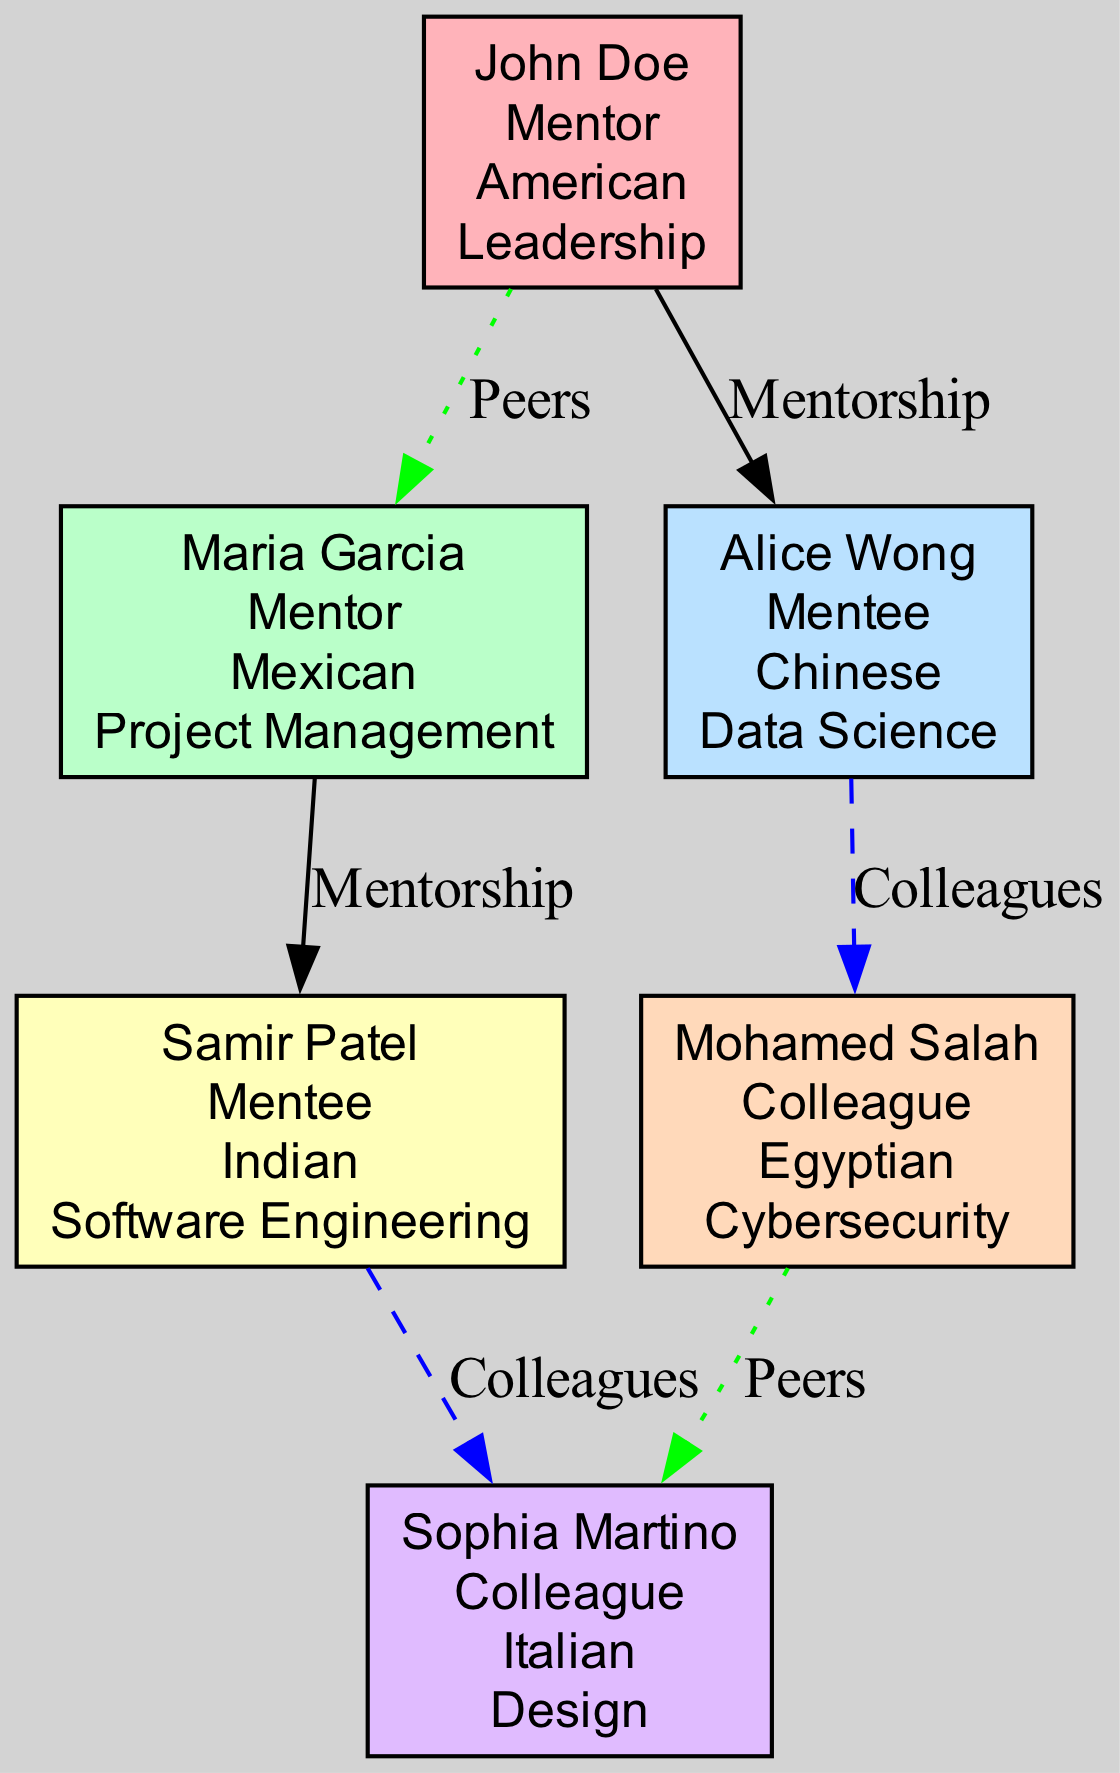What is John Doe's specialty? John Doe's node indicates that his specialty is "Leadership". By looking at the information in his node, we can directly find the specialty listed there.
Answer: Leadership How many mentees are represented in the diagram? The diagram shows two mentees: Alice Wong and Samir Patel. By counting the nodes with the role "Mentee", we find there are a total of two.
Answer: 2 What kind of relationship exists between Maria Garcia and Samir Patel? Since Maria Garcia is a mentor and Samir Patel is a mentee, the relationship is one of "Mentorship". However, we need to check the connections, and there is no direct connection between them. Therefore, the relationship is "None".
Answer: None Which cultural background does Sophia Martino represent? Sophia Martino's node lists her cultural background as "Italian". We can find this information directly in her node.
Answer: Italian What are the specialities of the colleagues listed in the diagram? The diagram includes two colleagues: Mohamed Salah, whose specialty is "Cybersecurity", and Sophia Martino, whose specialty is "Design". To find the specialties, we look at each colleague's node.
Answer: Cybersecurity and Design Who are the peers of John Doe? The diagram shows that John Doe has one peer, which is Maria Garcia. By examining the connections, we can identify that they are connected as peers.
Answer: Maria Garcia Which mentor specializes in Project Management? Maria Garcia's node specifies that her specialty is "Project Management". This information can be accessed directly from her node in the diagram.
Answer: Project Management How many connections are represented in the diagram? The total number of connections in the diagram is six as listed. We can count the connections shown in the data to reach this conclusion.
Answer: 6 What type of relationship do Alice Wong and Mohamed Salah have? Alice Wong and Mohamed Salah are connected through the relationship labeled "Colleagues". This relationship category can be verified by examining the connections in the diagram.
Answer: Colleagues What is the cultural background of Samir Patel? The node for Samir Patel indicates that his cultural background is "Indian". This information is found directly in his node.
Answer: Indian 